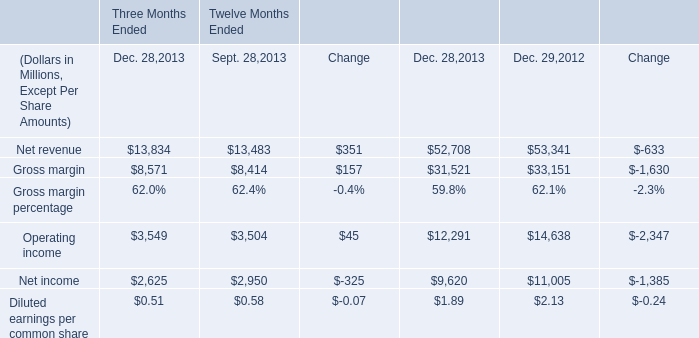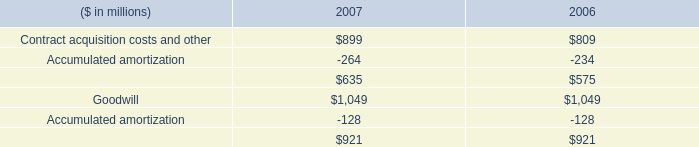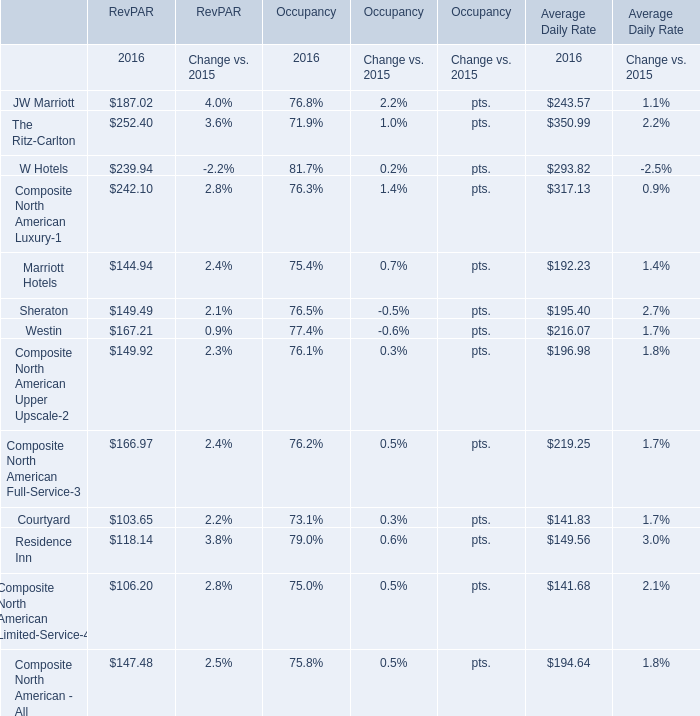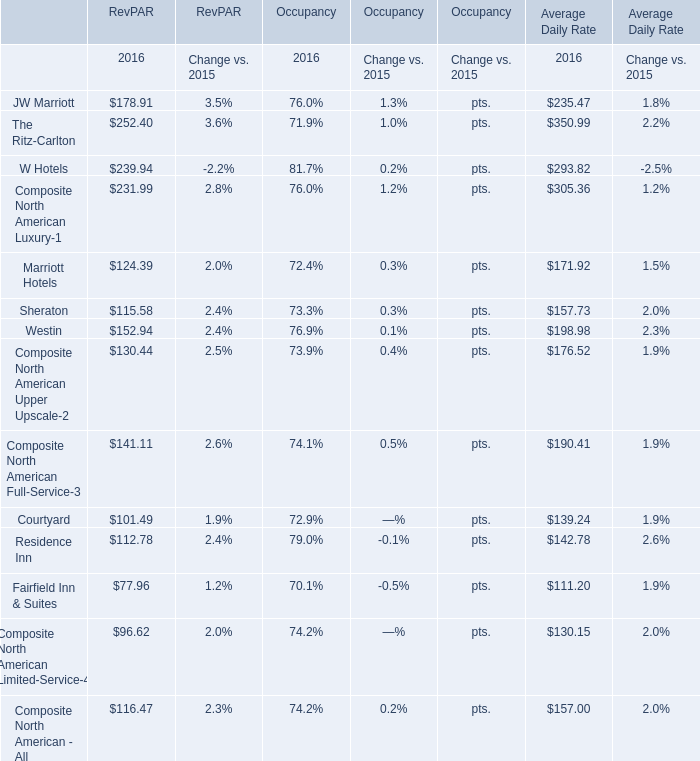What is the row number of the section for which the RevPAR in 2016 is greater than 240? 
Answer: 3. 